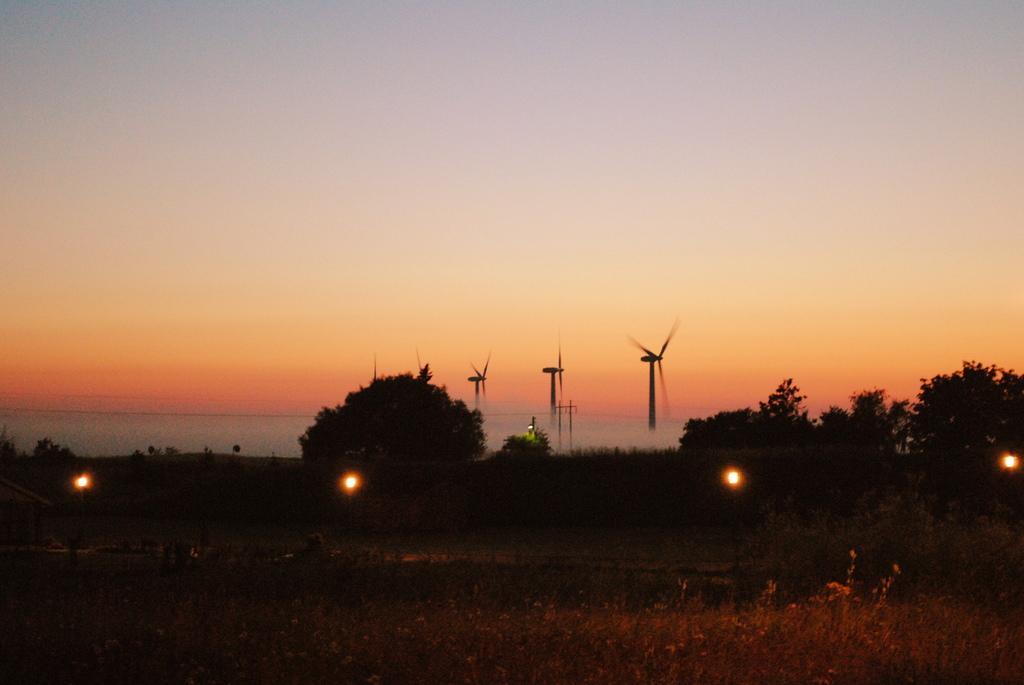Please provide a concise description of this image. In this image there is the sky, there are windmills, there are trees, there are lights, there are plants, there is a pole. 